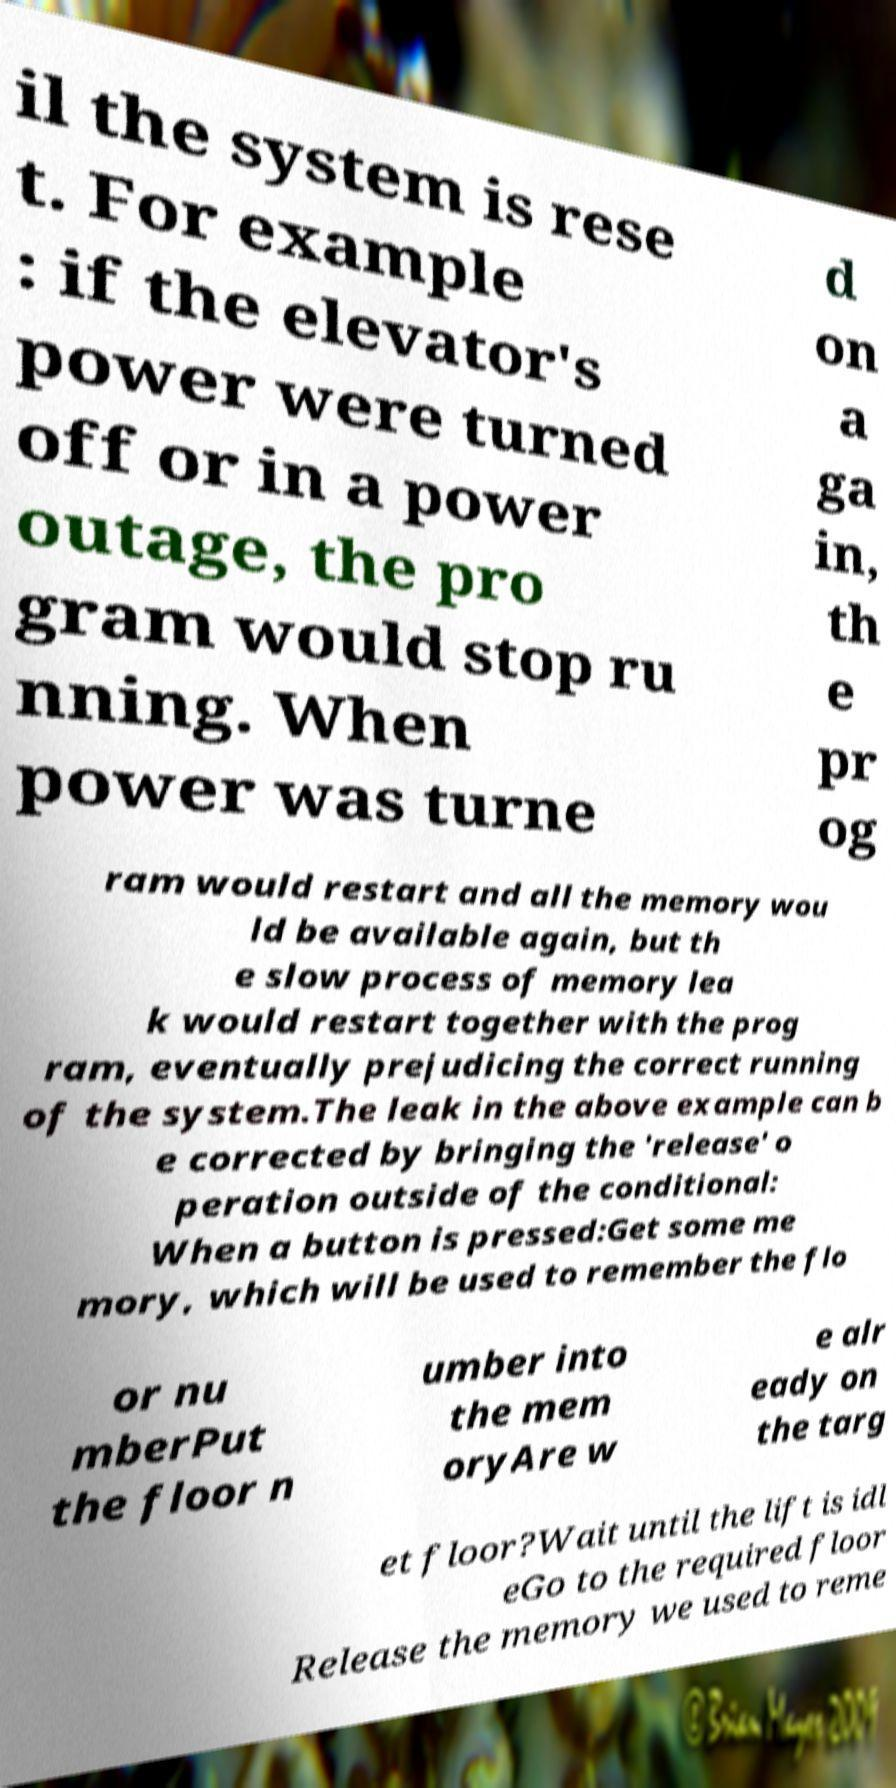Please read and relay the text visible in this image. What does it say? il the system is rese t. For example : if the elevator's power were turned off or in a power outage, the pro gram would stop ru nning. When power was turne d on a ga in, th e pr og ram would restart and all the memory wou ld be available again, but th e slow process of memory lea k would restart together with the prog ram, eventually prejudicing the correct running of the system.The leak in the above example can b e corrected by bringing the 'release' o peration outside of the conditional: When a button is pressed:Get some me mory, which will be used to remember the flo or nu mberPut the floor n umber into the mem oryAre w e alr eady on the targ et floor?Wait until the lift is idl eGo to the required floor Release the memory we used to reme 